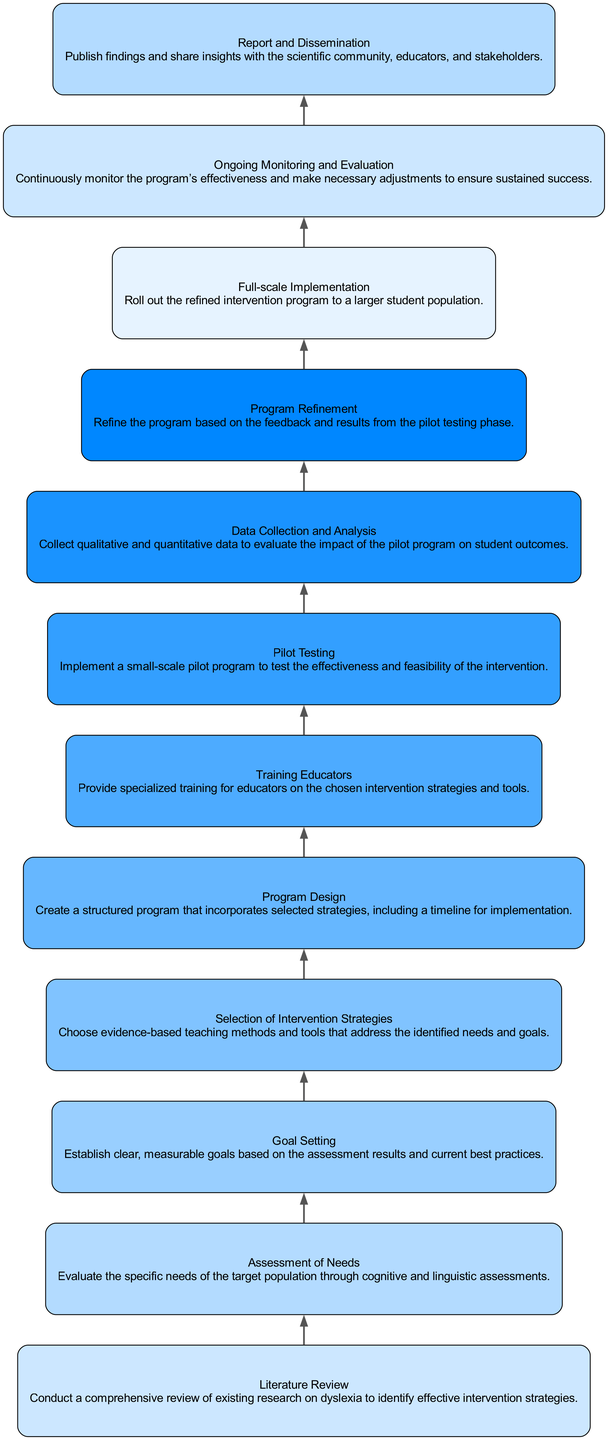What is the first step in the intervention program? The first step is "Literature Review" where a comprehensive review of existing research on dyslexia is conducted.
Answer: Literature Review How many steps are in the intervention program? There are a total of 12 steps in the intervention program as listed in the diagram.
Answer: 12 What comes after "Program Design"? The step that comes after "Program Design" is "Training Educators," where specialized training for educators is provided.
Answer: Training Educators What is the purpose of the "Pilot Testing" step? The purpose of "Pilot Testing" is to implement a small-scale pilot program to test the effectiveness and feasibility of the intervention.
Answer: Test effectiveness How does the "Assessment of Needs" relate to "Goal Setting"? "Assessment of Needs" evaluates the specific needs which help in establishing clear, measurable goals in "Goal Setting."
Answer: Establishing goals What is necessary for "Full-scale Implementation"? "Full-scale Implementation" requires a refined intervention program based on the pilot testing results.
Answer: Refined program How does "Data Collection and Analysis" contribute to the intervention program? "Data Collection and Analysis" collects qualitative and quantitative data to evaluate the impact of the program on student outcomes, aiding in program refinement.
Answer: Evaluates impact Which step focuses on sharing insights with stakeholders? The step that focuses on sharing insights with stakeholders is "Report and Dissemination," where findings are published and shared with relevant parties.
Answer: Report and Dissemination 